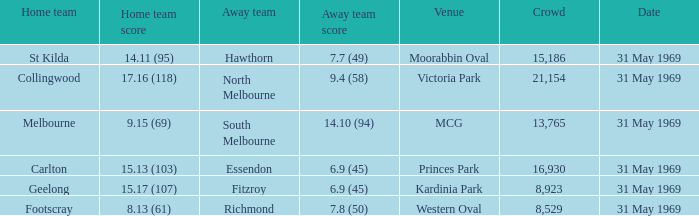In the game where the home team scored 15.17 (107), who was the away team? Fitzroy. 